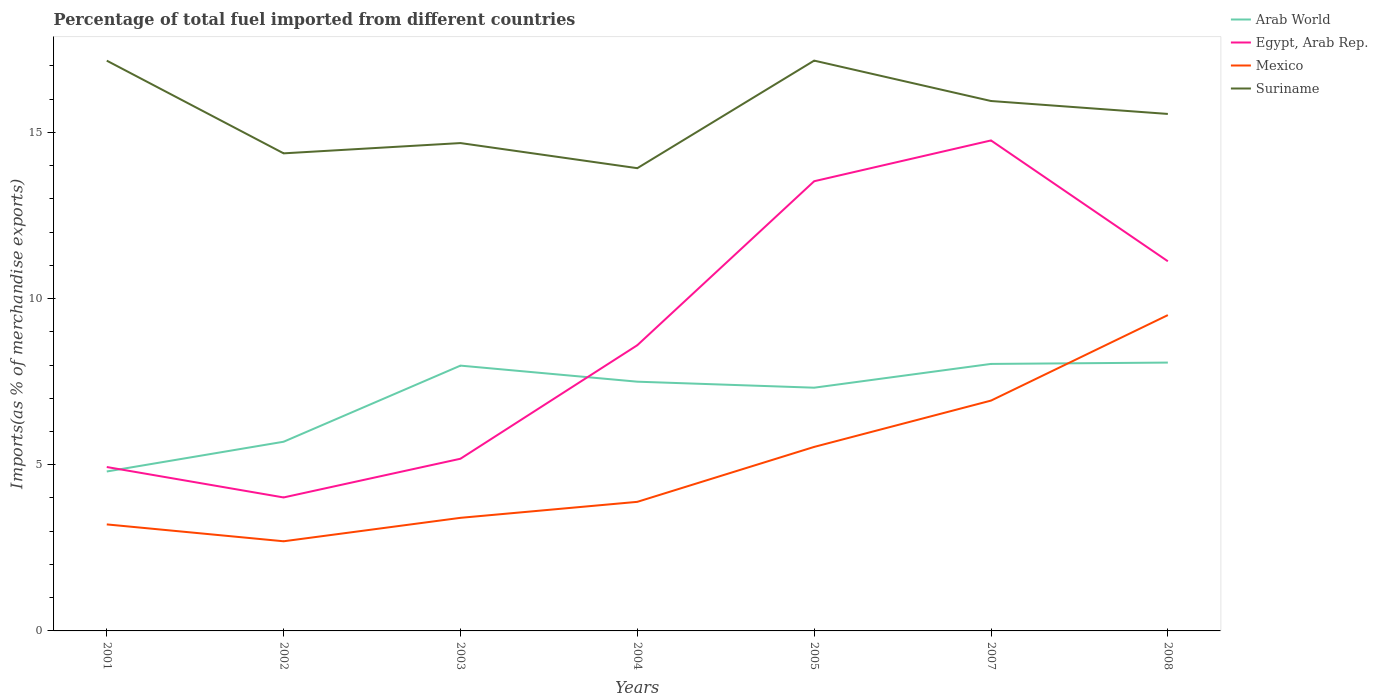How many different coloured lines are there?
Keep it short and to the point. 4. Does the line corresponding to Suriname intersect with the line corresponding to Egypt, Arab Rep.?
Your response must be concise. No. Is the number of lines equal to the number of legend labels?
Provide a short and direct response. Yes. Across all years, what is the maximum percentage of imports to different countries in Arab World?
Keep it short and to the point. 4.8. What is the total percentage of imports to different countries in Mexico in the graph?
Your answer should be very brief. -3.73. What is the difference between the highest and the second highest percentage of imports to different countries in Suriname?
Make the answer very short. 3.24. Is the percentage of imports to different countries in Egypt, Arab Rep. strictly greater than the percentage of imports to different countries in Mexico over the years?
Offer a terse response. No. How many lines are there?
Make the answer very short. 4. What is the difference between two consecutive major ticks on the Y-axis?
Your answer should be compact. 5. Does the graph contain any zero values?
Provide a short and direct response. No. Does the graph contain grids?
Give a very brief answer. No. Where does the legend appear in the graph?
Your answer should be very brief. Top right. How many legend labels are there?
Your response must be concise. 4. How are the legend labels stacked?
Your response must be concise. Vertical. What is the title of the graph?
Provide a succinct answer. Percentage of total fuel imported from different countries. What is the label or title of the X-axis?
Offer a very short reply. Years. What is the label or title of the Y-axis?
Your answer should be compact. Imports(as % of merchandise exports). What is the Imports(as % of merchandise exports) of Arab World in 2001?
Give a very brief answer. 4.8. What is the Imports(as % of merchandise exports) in Egypt, Arab Rep. in 2001?
Keep it short and to the point. 4.93. What is the Imports(as % of merchandise exports) of Mexico in 2001?
Keep it short and to the point. 3.21. What is the Imports(as % of merchandise exports) of Suriname in 2001?
Provide a short and direct response. 17.16. What is the Imports(as % of merchandise exports) of Arab World in 2002?
Your response must be concise. 5.69. What is the Imports(as % of merchandise exports) of Egypt, Arab Rep. in 2002?
Ensure brevity in your answer.  4.02. What is the Imports(as % of merchandise exports) of Mexico in 2002?
Provide a short and direct response. 2.7. What is the Imports(as % of merchandise exports) of Suriname in 2002?
Your answer should be compact. 14.37. What is the Imports(as % of merchandise exports) of Arab World in 2003?
Keep it short and to the point. 7.98. What is the Imports(as % of merchandise exports) of Egypt, Arab Rep. in 2003?
Provide a succinct answer. 5.18. What is the Imports(as % of merchandise exports) in Mexico in 2003?
Make the answer very short. 3.4. What is the Imports(as % of merchandise exports) of Suriname in 2003?
Make the answer very short. 14.68. What is the Imports(as % of merchandise exports) in Arab World in 2004?
Provide a succinct answer. 7.5. What is the Imports(as % of merchandise exports) of Egypt, Arab Rep. in 2004?
Provide a short and direct response. 8.6. What is the Imports(as % of merchandise exports) of Mexico in 2004?
Your answer should be very brief. 3.88. What is the Imports(as % of merchandise exports) of Suriname in 2004?
Keep it short and to the point. 13.92. What is the Imports(as % of merchandise exports) in Arab World in 2005?
Offer a very short reply. 7.32. What is the Imports(as % of merchandise exports) in Egypt, Arab Rep. in 2005?
Make the answer very short. 13.53. What is the Imports(as % of merchandise exports) in Mexico in 2005?
Offer a very short reply. 5.54. What is the Imports(as % of merchandise exports) in Suriname in 2005?
Keep it short and to the point. 17.16. What is the Imports(as % of merchandise exports) in Arab World in 2007?
Provide a short and direct response. 8.03. What is the Imports(as % of merchandise exports) of Egypt, Arab Rep. in 2007?
Provide a short and direct response. 14.76. What is the Imports(as % of merchandise exports) in Mexico in 2007?
Provide a succinct answer. 6.93. What is the Imports(as % of merchandise exports) of Suriname in 2007?
Your answer should be compact. 15.95. What is the Imports(as % of merchandise exports) in Arab World in 2008?
Ensure brevity in your answer.  8.07. What is the Imports(as % of merchandise exports) of Egypt, Arab Rep. in 2008?
Your answer should be compact. 11.12. What is the Imports(as % of merchandise exports) of Mexico in 2008?
Offer a very short reply. 9.5. What is the Imports(as % of merchandise exports) of Suriname in 2008?
Give a very brief answer. 15.56. Across all years, what is the maximum Imports(as % of merchandise exports) of Arab World?
Your response must be concise. 8.07. Across all years, what is the maximum Imports(as % of merchandise exports) in Egypt, Arab Rep.?
Offer a terse response. 14.76. Across all years, what is the maximum Imports(as % of merchandise exports) of Mexico?
Offer a terse response. 9.5. Across all years, what is the maximum Imports(as % of merchandise exports) of Suriname?
Provide a succinct answer. 17.16. Across all years, what is the minimum Imports(as % of merchandise exports) of Arab World?
Provide a short and direct response. 4.8. Across all years, what is the minimum Imports(as % of merchandise exports) of Egypt, Arab Rep.?
Your response must be concise. 4.02. Across all years, what is the minimum Imports(as % of merchandise exports) in Mexico?
Keep it short and to the point. 2.7. Across all years, what is the minimum Imports(as % of merchandise exports) in Suriname?
Provide a short and direct response. 13.92. What is the total Imports(as % of merchandise exports) in Arab World in the graph?
Your response must be concise. 49.4. What is the total Imports(as % of merchandise exports) in Egypt, Arab Rep. in the graph?
Your response must be concise. 62.14. What is the total Imports(as % of merchandise exports) in Mexico in the graph?
Make the answer very short. 35.16. What is the total Imports(as % of merchandise exports) of Suriname in the graph?
Make the answer very short. 108.8. What is the difference between the Imports(as % of merchandise exports) of Arab World in 2001 and that in 2002?
Make the answer very short. -0.9. What is the difference between the Imports(as % of merchandise exports) of Egypt, Arab Rep. in 2001 and that in 2002?
Your response must be concise. 0.92. What is the difference between the Imports(as % of merchandise exports) of Mexico in 2001 and that in 2002?
Your answer should be very brief. 0.51. What is the difference between the Imports(as % of merchandise exports) of Suriname in 2001 and that in 2002?
Offer a very short reply. 2.79. What is the difference between the Imports(as % of merchandise exports) in Arab World in 2001 and that in 2003?
Give a very brief answer. -3.19. What is the difference between the Imports(as % of merchandise exports) of Egypt, Arab Rep. in 2001 and that in 2003?
Give a very brief answer. -0.25. What is the difference between the Imports(as % of merchandise exports) of Mexico in 2001 and that in 2003?
Offer a terse response. -0.2. What is the difference between the Imports(as % of merchandise exports) in Suriname in 2001 and that in 2003?
Give a very brief answer. 2.48. What is the difference between the Imports(as % of merchandise exports) of Arab World in 2001 and that in 2004?
Provide a succinct answer. -2.7. What is the difference between the Imports(as % of merchandise exports) of Egypt, Arab Rep. in 2001 and that in 2004?
Ensure brevity in your answer.  -3.67. What is the difference between the Imports(as % of merchandise exports) of Mexico in 2001 and that in 2004?
Ensure brevity in your answer.  -0.68. What is the difference between the Imports(as % of merchandise exports) in Suriname in 2001 and that in 2004?
Provide a succinct answer. 3.24. What is the difference between the Imports(as % of merchandise exports) of Arab World in 2001 and that in 2005?
Make the answer very short. -2.52. What is the difference between the Imports(as % of merchandise exports) of Egypt, Arab Rep. in 2001 and that in 2005?
Your answer should be compact. -8.6. What is the difference between the Imports(as % of merchandise exports) in Mexico in 2001 and that in 2005?
Your answer should be compact. -2.33. What is the difference between the Imports(as % of merchandise exports) in Suriname in 2001 and that in 2005?
Give a very brief answer. -0. What is the difference between the Imports(as % of merchandise exports) in Arab World in 2001 and that in 2007?
Make the answer very short. -3.24. What is the difference between the Imports(as % of merchandise exports) in Egypt, Arab Rep. in 2001 and that in 2007?
Give a very brief answer. -9.83. What is the difference between the Imports(as % of merchandise exports) in Mexico in 2001 and that in 2007?
Your response must be concise. -3.73. What is the difference between the Imports(as % of merchandise exports) in Suriname in 2001 and that in 2007?
Provide a short and direct response. 1.21. What is the difference between the Imports(as % of merchandise exports) of Arab World in 2001 and that in 2008?
Give a very brief answer. -3.28. What is the difference between the Imports(as % of merchandise exports) of Egypt, Arab Rep. in 2001 and that in 2008?
Ensure brevity in your answer.  -6.19. What is the difference between the Imports(as % of merchandise exports) of Mexico in 2001 and that in 2008?
Offer a terse response. -6.3. What is the difference between the Imports(as % of merchandise exports) of Suriname in 2001 and that in 2008?
Offer a very short reply. 1.6. What is the difference between the Imports(as % of merchandise exports) in Arab World in 2002 and that in 2003?
Provide a succinct answer. -2.29. What is the difference between the Imports(as % of merchandise exports) in Egypt, Arab Rep. in 2002 and that in 2003?
Offer a very short reply. -1.16. What is the difference between the Imports(as % of merchandise exports) of Mexico in 2002 and that in 2003?
Give a very brief answer. -0.71. What is the difference between the Imports(as % of merchandise exports) of Suriname in 2002 and that in 2003?
Ensure brevity in your answer.  -0.31. What is the difference between the Imports(as % of merchandise exports) in Arab World in 2002 and that in 2004?
Offer a terse response. -1.81. What is the difference between the Imports(as % of merchandise exports) in Egypt, Arab Rep. in 2002 and that in 2004?
Your response must be concise. -4.58. What is the difference between the Imports(as % of merchandise exports) in Mexico in 2002 and that in 2004?
Give a very brief answer. -1.19. What is the difference between the Imports(as % of merchandise exports) of Suriname in 2002 and that in 2004?
Make the answer very short. 0.45. What is the difference between the Imports(as % of merchandise exports) of Arab World in 2002 and that in 2005?
Provide a succinct answer. -1.63. What is the difference between the Imports(as % of merchandise exports) in Egypt, Arab Rep. in 2002 and that in 2005?
Provide a succinct answer. -9.51. What is the difference between the Imports(as % of merchandise exports) of Mexico in 2002 and that in 2005?
Provide a succinct answer. -2.84. What is the difference between the Imports(as % of merchandise exports) in Suriname in 2002 and that in 2005?
Offer a very short reply. -2.79. What is the difference between the Imports(as % of merchandise exports) in Arab World in 2002 and that in 2007?
Offer a very short reply. -2.34. What is the difference between the Imports(as % of merchandise exports) in Egypt, Arab Rep. in 2002 and that in 2007?
Make the answer very short. -10.74. What is the difference between the Imports(as % of merchandise exports) of Mexico in 2002 and that in 2007?
Offer a terse response. -4.23. What is the difference between the Imports(as % of merchandise exports) of Suriname in 2002 and that in 2007?
Your answer should be compact. -1.57. What is the difference between the Imports(as % of merchandise exports) of Arab World in 2002 and that in 2008?
Give a very brief answer. -2.38. What is the difference between the Imports(as % of merchandise exports) in Egypt, Arab Rep. in 2002 and that in 2008?
Make the answer very short. -7.11. What is the difference between the Imports(as % of merchandise exports) of Mexico in 2002 and that in 2008?
Your answer should be compact. -6.81. What is the difference between the Imports(as % of merchandise exports) of Suriname in 2002 and that in 2008?
Provide a short and direct response. -1.19. What is the difference between the Imports(as % of merchandise exports) in Arab World in 2003 and that in 2004?
Provide a succinct answer. 0.48. What is the difference between the Imports(as % of merchandise exports) in Egypt, Arab Rep. in 2003 and that in 2004?
Your response must be concise. -3.42. What is the difference between the Imports(as % of merchandise exports) in Mexico in 2003 and that in 2004?
Ensure brevity in your answer.  -0.48. What is the difference between the Imports(as % of merchandise exports) of Suriname in 2003 and that in 2004?
Provide a succinct answer. 0.76. What is the difference between the Imports(as % of merchandise exports) of Arab World in 2003 and that in 2005?
Ensure brevity in your answer.  0.66. What is the difference between the Imports(as % of merchandise exports) in Egypt, Arab Rep. in 2003 and that in 2005?
Ensure brevity in your answer.  -8.35. What is the difference between the Imports(as % of merchandise exports) in Mexico in 2003 and that in 2005?
Offer a very short reply. -2.13. What is the difference between the Imports(as % of merchandise exports) of Suriname in 2003 and that in 2005?
Your answer should be very brief. -2.48. What is the difference between the Imports(as % of merchandise exports) in Arab World in 2003 and that in 2007?
Offer a very short reply. -0.05. What is the difference between the Imports(as % of merchandise exports) in Egypt, Arab Rep. in 2003 and that in 2007?
Give a very brief answer. -9.58. What is the difference between the Imports(as % of merchandise exports) in Mexico in 2003 and that in 2007?
Offer a very short reply. -3.53. What is the difference between the Imports(as % of merchandise exports) of Suriname in 2003 and that in 2007?
Your answer should be very brief. -1.27. What is the difference between the Imports(as % of merchandise exports) in Arab World in 2003 and that in 2008?
Provide a short and direct response. -0.09. What is the difference between the Imports(as % of merchandise exports) of Egypt, Arab Rep. in 2003 and that in 2008?
Offer a very short reply. -5.94. What is the difference between the Imports(as % of merchandise exports) of Mexico in 2003 and that in 2008?
Provide a succinct answer. -6.1. What is the difference between the Imports(as % of merchandise exports) in Suriname in 2003 and that in 2008?
Offer a terse response. -0.88. What is the difference between the Imports(as % of merchandise exports) of Arab World in 2004 and that in 2005?
Ensure brevity in your answer.  0.18. What is the difference between the Imports(as % of merchandise exports) of Egypt, Arab Rep. in 2004 and that in 2005?
Your response must be concise. -4.93. What is the difference between the Imports(as % of merchandise exports) of Mexico in 2004 and that in 2005?
Your answer should be very brief. -1.65. What is the difference between the Imports(as % of merchandise exports) of Suriname in 2004 and that in 2005?
Offer a terse response. -3.24. What is the difference between the Imports(as % of merchandise exports) in Arab World in 2004 and that in 2007?
Your response must be concise. -0.53. What is the difference between the Imports(as % of merchandise exports) in Egypt, Arab Rep. in 2004 and that in 2007?
Offer a terse response. -6.16. What is the difference between the Imports(as % of merchandise exports) of Mexico in 2004 and that in 2007?
Your answer should be very brief. -3.05. What is the difference between the Imports(as % of merchandise exports) in Suriname in 2004 and that in 2007?
Offer a very short reply. -2.02. What is the difference between the Imports(as % of merchandise exports) in Arab World in 2004 and that in 2008?
Your response must be concise. -0.57. What is the difference between the Imports(as % of merchandise exports) of Egypt, Arab Rep. in 2004 and that in 2008?
Offer a terse response. -2.53. What is the difference between the Imports(as % of merchandise exports) in Mexico in 2004 and that in 2008?
Your answer should be very brief. -5.62. What is the difference between the Imports(as % of merchandise exports) of Suriname in 2004 and that in 2008?
Offer a very short reply. -1.63. What is the difference between the Imports(as % of merchandise exports) in Arab World in 2005 and that in 2007?
Offer a very short reply. -0.72. What is the difference between the Imports(as % of merchandise exports) of Egypt, Arab Rep. in 2005 and that in 2007?
Offer a terse response. -1.23. What is the difference between the Imports(as % of merchandise exports) in Mexico in 2005 and that in 2007?
Your response must be concise. -1.39. What is the difference between the Imports(as % of merchandise exports) in Suriname in 2005 and that in 2007?
Your answer should be compact. 1.22. What is the difference between the Imports(as % of merchandise exports) in Arab World in 2005 and that in 2008?
Your response must be concise. -0.76. What is the difference between the Imports(as % of merchandise exports) in Egypt, Arab Rep. in 2005 and that in 2008?
Keep it short and to the point. 2.41. What is the difference between the Imports(as % of merchandise exports) in Mexico in 2005 and that in 2008?
Provide a succinct answer. -3.97. What is the difference between the Imports(as % of merchandise exports) of Suriname in 2005 and that in 2008?
Provide a short and direct response. 1.6. What is the difference between the Imports(as % of merchandise exports) in Arab World in 2007 and that in 2008?
Offer a very short reply. -0.04. What is the difference between the Imports(as % of merchandise exports) of Egypt, Arab Rep. in 2007 and that in 2008?
Provide a succinct answer. 3.64. What is the difference between the Imports(as % of merchandise exports) in Mexico in 2007 and that in 2008?
Provide a short and direct response. -2.57. What is the difference between the Imports(as % of merchandise exports) in Suriname in 2007 and that in 2008?
Keep it short and to the point. 0.39. What is the difference between the Imports(as % of merchandise exports) of Arab World in 2001 and the Imports(as % of merchandise exports) of Egypt, Arab Rep. in 2002?
Give a very brief answer. 0.78. What is the difference between the Imports(as % of merchandise exports) in Arab World in 2001 and the Imports(as % of merchandise exports) in Mexico in 2002?
Provide a short and direct response. 2.1. What is the difference between the Imports(as % of merchandise exports) of Arab World in 2001 and the Imports(as % of merchandise exports) of Suriname in 2002?
Provide a succinct answer. -9.57. What is the difference between the Imports(as % of merchandise exports) in Egypt, Arab Rep. in 2001 and the Imports(as % of merchandise exports) in Mexico in 2002?
Give a very brief answer. 2.23. What is the difference between the Imports(as % of merchandise exports) in Egypt, Arab Rep. in 2001 and the Imports(as % of merchandise exports) in Suriname in 2002?
Give a very brief answer. -9.44. What is the difference between the Imports(as % of merchandise exports) of Mexico in 2001 and the Imports(as % of merchandise exports) of Suriname in 2002?
Your response must be concise. -11.17. What is the difference between the Imports(as % of merchandise exports) of Arab World in 2001 and the Imports(as % of merchandise exports) of Egypt, Arab Rep. in 2003?
Your answer should be very brief. -0.38. What is the difference between the Imports(as % of merchandise exports) of Arab World in 2001 and the Imports(as % of merchandise exports) of Mexico in 2003?
Provide a succinct answer. 1.39. What is the difference between the Imports(as % of merchandise exports) of Arab World in 2001 and the Imports(as % of merchandise exports) of Suriname in 2003?
Your answer should be very brief. -9.88. What is the difference between the Imports(as % of merchandise exports) of Egypt, Arab Rep. in 2001 and the Imports(as % of merchandise exports) of Mexico in 2003?
Keep it short and to the point. 1.53. What is the difference between the Imports(as % of merchandise exports) in Egypt, Arab Rep. in 2001 and the Imports(as % of merchandise exports) in Suriname in 2003?
Your answer should be very brief. -9.75. What is the difference between the Imports(as % of merchandise exports) in Mexico in 2001 and the Imports(as % of merchandise exports) in Suriname in 2003?
Keep it short and to the point. -11.47. What is the difference between the Imports(as % of merchandise exports) of Arab World in 2001 and the Imports(as % of merchandise exports) of Egypt, Arab Rep. in 2004?
Your answer should be compact. -3.8. What is the difference between the Imports(as % of merchandise exports) in Arab World in 2001 and the Imports(as % of merchandise exports) in Mexico in 2004?
Offer a terse response. 0.91. What is the difference between the Imports(as % of merchandise exports) in Arab World in 2001 and the Imports(as % of merchandise exports) in Suriname in 2004?
Offer a terse response. -9.13. What is the difference between the Imports(as % of merchandise exports) of Egypt, Arab Rep. in 2001 and the Imports(as % of merchandise exports) of Mexico in 2004?
Your answer should be very brief. 1.05. What is the difference between the Imports(as % of merchandise exports) of Egypt, Arab Rep. in 2001 and the Imports(as % of merchandise exports) of Suriname in 2004?
Give a very brief answer. -8.99. What is the difference between the Imports(as % of merchandise exports) of Mexico in 2001 and the Imports(as % of merchandise exports) of Suriname in 2004?
Ensure brevity in your answer.  -10.72. What is the difference between the Imports(as % of merchandise exports) in Arab World in 2001 and the Imports(as % of merchandise exports) in Egypt, Arab Rep. in 2005?
Your response must be concise. -8.73. What is the difference between the Imports(as % of merchandise exports) of Arab World in 2001 and the Imports(as % of merchandise exports) of Mexico in 2005?
Offer a very short reply. -0.74. What is the difference between the Imports(as % of merchandise exports) in Arab World in 2001 and the Imports(as % of merchandise exports) in Suriname in 2005?
Make the answer very short. -12.36. What is the difference between the Imports(as % of merchandise exports) in Egypt, Arab Rep. in 2001 and the Imports(as % of merchandise exports) in Mexico in 2005?
Ensure brevity in your answer.  -0.6. What is the difference between the Imports(as % of merchandise exports) of Egypt, Arab Rep. in 2001 and the Imports(as % of merchandise exports) of Suriname in 2005?
Ensure brevity in your answer.  -12.23. What is the difference between the Imports(as % of merchandise exports) of Mexico in 2001 and the Imports(as % of merchandise exports) of Suriname in 2005?
Make the answer very short. -13.96. What is the difference between the Imports(as % of merchandise exports) in Arab World in 2001 and the Imports(as % of merchandise exports) in Egypt, Arab Rep. in 2007?
Provide a short and direct response. -9.96. What is the difference between the Imports(as % of merchandise exports) of Arab World in 2001 and the Imports(as % of merchandise exports) of Mexico in 2007?
Keep it short and to the point. -2.13. What is the difference between the Imports(as % of merchandise exports) in Arab World in 2001 and the Imports(as % of merchandise exports) in Suriname in 2007?
Offer a terse response. -11.15. What is the difference between the Imports(as % of merchandise exports) of Egypt, Arab Rep. in 2001 and the Imports(as % of merchandise exports) of Mexico in 2007?
Offer a terse response. -2. What is the difference between the Imports(as % of merchandise exports) of Egypt, Arab Rep. in 2001 and the Imports(as % of merchandise exports) of Suriname in 2007?
Keep it short and to the point. -11.01. What is the difference between the Imports(as % of merchandise exports) of Mexico in 2001 and the Imports(as % of merchandise exports) of Suriname in 2007?
Give a very brief answer. -12.74. What is the difference between the Imports(as % of merchandise exports) in Arab World in 2001 and the Imports(as % of merchandise exports) in Egypt, Arab Rep. in 2008?
Make the answer very short. -6.33. What is the difference between the Imports(as % of merchandise exports) in Arab World in 2001 and the Imports(as % of merchandise exports) in Mexico in 2008?
Provide a succinct answer. -4.71. What is the difference between the Imports(as % of merchandise exports) of Arab World in 2001 and the Imports(as % of merchandise exports) of Suriname in 2008?
Make the answer very short. -10.76. What is the difference between the Imports(as % of merchandise exports) of Egypt, Arab Rep. in 2001 and the Imports(as % of merchandise exports) of Mexico in 2008?
Your answer should be compact. -4.57. What is the difference between the Imports(as % of merchandise exports) in Egypt, Arab Rep. in 2001 and the Imports(as % of merchandise exports) in Suriname in 2008?
Give a very brief answer. -10.62. What is the difference between the Imports(as % of merchandise exports) of Mexico in 2001 and the Imports(as % of merchandise exports) of Suriname in 2008?
Keep it short and to the point. -12.35. What is the difference between the Imports(as % of merchandise exports) in Arab World in 2002 and the Imports(as % of merchandise exports) in Egypt, Arab Rep. in 2003?
Ensure brevity in your answer.  0.51. What is the difference between the Imports(as % of merchandise exports) in Arab World in 2002 and the Imports(as % of merchandise exports) in Mexico in 2003?
Provide a short and direct response. 2.29. What is the difference between the Imports(as % of merchandise exports) of Arab World in 2002 and the Imports(as % of merchandise exports) of Suriname in 2003?
Provide a succinct answer. -8.99. What is the difference between the Imports(as % of merchandise exports) of Egypt, Arab Rep. in 2002 and the Imports(as % of merchandise exports) of Mexico in 2003?
Offer a very short reply. 0.61. What is the difference between the Imports(as % of merchandise exports) in Egypt, Arab Rep. in 2002 and the Imports(as % of merchandise exports) in Suriname in 2003?
Provide a short and direct response. -10.66. What is the difference between the Imports(as % of merchandise exports) of Mexico in 2002 and the Imports(as % of merchandise exports) of Suriname in 2003?
Give a very brief answer. -11.98. What is the difference between the Imports(as % of merchandise exports) of Arab World in 2002 and the Imports(as % of merchandise exports) of Egypt, Arab Rep. in 2004?
Offer a very short reply. -2.9. What is the difference between the Imports(as % of merchandise exports) of Arab World in 2002 and the Imports(as % of merchandise exports) of Mexico in 2004?
Make the answer very short. 1.81. What is the difference between the Imports(as % of merchandise exports) in Arab World in 2002 and the Imports(as % of merchandise exports) in Suriname in 2004?
Offer a very short reply. -8.23. What is the difference between the Imports(as % of merchandise exports) of Egypt, Arab Rep. in 2002 and the Imports(as % of merchandise exports) of Mexico in 2004?
Make the answer very short. 0.13. What is the difference between the Imports(as % of merchandise exports) in Egypt, Arab Rep. in 2002 and the Imports(as % of merchandise exports) in Suriname in 2004?
Provide a short and direct response. -9.91. What is the difference between the Imports(as % of merchandise exports) of Mexico in 2002 and the Imports(as % of merchandise exports) of Suriname in 2004?
Make the answer very short. -11.23. What is the difference between the Imports(as % of merchandise exports) in Arab World in 2002 and the Imports(as % of merchandise exports) in Egypt, Arab Rep. in 2005?
Ensure brevity in your answer.  -7.84. What is the difference between the Imports(as % of merchandise exports) in Arab World in 2002 and the Imports(as % of merchandise exports) in Mexico in 2005?
Give a very brief answer. 0.16. What is the difference between the Imports(as % of merchandise exports) in Arab World in 2002 and the Imports(as % of merchandise exports) in Suriname in 2005?
Ensure brevity in your answer.  -11.47. What is the difference between the Imports(as % of merchandise exports) of Egypt, Arab Rep. in 2002 and the Imports(as % of merchandise exports) of Mexico in 2005?
Ensure brevity in your answer.  -1.52. What is the difference between the Imports(as % of merchandise exports) in Egypt, Arab Rep. in 2002 and the Imports(as % of merchandise exports) in Suriname in 2005?
Ensure brevity in your answer.  -13.14. What is the difference between the Imports(as % of merchandise exports) in Mexico in 2002 and the Imports(as % of merchandise exports) in Suriname in 2005?
Keep it short and to the point. -14.46. What is the difference between the Imports(as % of merchandise exports) of Arab World in 2002 and the Imports(as % of merchandise exports) of Egypt, Arab Rep. in 2007?
Provide a short and direct response. -9.07. What is the difference between the Imports(as % of merchandise exports) in Arab World in 2002 and the Imports(as % of merchandise exports) in Mexico in 2007?
Your response must be concise. -1.24. What is the difference between the Imports(as % of merchandise exports) of Arab World in 2002 and the Imports(as % of merchandise exports) of Suriname in 2007?
Your response must be concise. -10.25. What is the difference between the Imports(as % of merchandise exports) in Egypt, Arab Rep. in 2002 and the Imports(as % of merchandise exports) in Mexico in 2007?
Provide a short and direct response. -2.91. What is the difference between the Imports(as % of merchandise exports) in Egypt, Arab Rep. in 2002 and the Imports(as % of merchandise exports) in Suriname in 2007?
Your answer should be very brief. -11.93. What is the difference between the Imports(as % of merchandise exports) of Mexico in 2002 and the Imports(as % of merchandise exports) of Suriname in 2007?
Your answer should be compact. -13.25. What is the difference between the Imports(as % of merchandise exports) in Arab World in 2002 and the Imports(as % of merchandise exports) in Egypt, Arab Rep. in 2008?
Your answer should be compact. -5.43. What is the difference between the Imports(as % of merchandise exports) in Arab World in 2002 and the Imports(as % of merchandise exports) in Mexico in 2008?
Ensure brevity in your answer.  -3.81. What is the difference between the Imports(as % of merchandise exports) of Arab World in 2002 and the Imports(as % of merchandise exports) of Suriname in 2008?
Keep it short and to the point. -9.86. What is the difference between the Imports(as % of merchandise exports) of Egypt, Arab Rep. in 2002 and the Imports(as % of merchandise exports) of Mexico in 2008?
Your answer should be very brief. -5.49. What is the difference between the Imports(as % of merchandise exports) in Egypt, Arab Rep. in 2002 and the Imports(as % of merchandise exports) in Suriname in 2008?
Your response must be concise. -11.54. What is the difference between the Imports(as % of merchandise exports) of Mexico in 2002 and the Imports(as % of merchandise exports) of Suriname in 2008?
Offer a terse response. -12.86. What is the difference between the Imports(as % of merchandise exports) in Arab World in 2003 and the Imports(as % of merchandise exports) in Egypt, Arab Rep. in 2004?
Give a very brief answer. -0.61. What is the difference between the Imports(as % of merchandise exports) in Arab World in 2003 and the Imports(as % of merchandise exports) in Mexico in 2004?
Ensure brevity in your answer.  4.1. What is the difference between the Imports(as % of merchandise exports) of Arab World in 2003 and the Imports(as % of merchandise exports) of Suriname in 2004?
Give a very brief answer. -5.94. What is the difference between the Imports(as % of merchandise exports) in Egypt, Arab Rep. in 2003 and the Imports(as % of merchandise exports) in Mexico in 2004?
Provide a succinct answer. 1.3. What is the difference between the Imports(as % of merchandise exports) of Egypt, Arab Rep. in 2003 and the Imports(as % of merchandise exports) of Suriname in 2004?
Offer a terse response. -8.74. What is the difference between the Imports(as % of merchandise exports) of Mexico in 2003 and the Imports(as % of merchandise exports) of Suriname in 2004?
Your answer should be compact. -10.52. What is the difference between the Imports(as % of merchandise exports) of Arab World in 2003 and the Imports(as % of merchandise exports) of Egypt, Arab Rep. in 2005?
Provide a succinct answer. -5.55. What is the difference between the Imports(as % of merchandise exports) of Arab World in 2003 and the Imports(as % of merchandise exports) of Mexico in 2005?
Your answer should be very brief. 2.45. What is the difference between the Imports(as % of merchandise exports) in Arab World in 2003 and the Imports(as % of merchandise exports) in Suriname in 2005?
Provide a short and direct response. -9.18. What is the difference between the Imports(as % of merchandise exports) in Egypt, Arab Rep. in 2003 and the Imports(as % of merchandise exports) in Mexico in 2005?
Your answer should be compact. -0.36. What is the difference between the Imports(as % of merchandise exports) of Egypt, Arab Rep. in 2003 and the Imports(as % of merchandise exports) of Suriname in 2005?
Give a very brief answer. -11.98. What is the difference between the Imports(as % of merchandise exports) of Mexico in 2003 and the Imports(as % of merchandise exports) of Suriname in 2005?
Keep it short and to the point. -13.76. What is the difference between the Imports(as % of merchandise exports) of Arab World in 2003 and the Imports(as % of merchandise exports) of Egypt, Arab Rep. in 2007?
Your answer should be compact. -6.78. What is the difference between the Imports(as % of merchandise exports) in Arab World in 2003 and the Imports(as % of merchandise exports) in Mexico in 2007?
Your answer should be very brief. 1.05. What is the difference between the Imports(as % of merchandise exports) in Arab World in 2003 and the Imports(as % of merchandise exports) in Suriname in 2007?
Ensure brevity in your answer.  -7.96. What is the difference between the Imports(as % of merchandise exports) in Egypt, Arab Rep. in 2003 and the Imports(as % of merchandise exports) in Mexico in 2007?
Provide a short and direct response. -1.75. What is the difference between the Imports(as % of merchandise exports) of Egypt, Arab Rep. in 2003 and the Imports(as % of merchandise exports) of Suriname in 2007?
Your answer should be compact. -10.76. What is the difference between the Imports(as % of merchandise exports) of Mexico in 2003 and the Imports(as % of merchandise exports) of Suriname in 2007?
Your answer should be compact. -12.54. What is the difference between the Imports(as % of merchandise exports) in Arab World in 2003 and the Imports(as % of merchandise exports) in Egypt, Arab Rep. in 2008?
Your answer should be compact. -3.14. What is the difference between the Imports(as % of merchandise exports) of Arab World in 2003 and the Imports(as % of merchandise exports) of Mexico in 2008?
Provide a short and direct response. -1.52. What is the difference between the Imports(as % of merchandise exports) in Arab World in 2003 and the Imports(as % of merchandise exports) in Suriname in 2008?
Make the answer very short. -7.57. What is the difference between the Imports(as % of merchandise exports) of Egypt, Arab Rep. in 2003 and the Imports(as % of merchandise exports) of Mexico in 2008?
Give a very brief answer. -4.32. What is the difference between the Imports(as % of merchandise exports) in Egypt, Arab Rep. in 2003 and the Imports(as % of merchandise exports) in Suriname in 2008?
Ensure brevity in your answer.  -10.38. What is the difference between the Imports(as % of merchandise exports) in Mexico in 2003 and the Imports(as % of merchandise exports) in Suriname in 2008?
Give a very brief answer. -12.15. What is the difference between the Imports(as % of merchandise exports) in Arab World in 2004 and the Imports(as % of merchandise exports) in Egypt, Arab Rep. in 2005?
Provide a succinct answer. -6.03. What is the difference between the Imports(as % of merchandise exports) in Arab World in 2004 and the Imports(as % of merchandise exports) in Mexico in 2005?
Give a very brief answer. 1.96. What is the difference between the Imports(as % of merchandise exports) of Arab World in 2004 and the Imports(as % of merchandise exports) of Suriname in 2005?
Offer a very short reply. -9.66. What is the difference between the Imports(as % of merchandise exports) in Egypt, Arab Rep. in 2004 and the Imports(as % of merchandise exports) in Mexico in 2005?
Your answer should be compact. 3.06. What is the difference between the Imports(as % of merchandise exports) in Egypt, Arab Rep. in 2004 and the Imports(as % of merchandise exports) in Suriname in 2005?
Offer a very short reply. -8.56. What is the difference between the Imports(as % of merchandise exports) in Mexico in 2004 and the Imports(as % of merchandise exports) in Suriname in 2005?
Give a very brief answer. -13.28. What is the difference between the Imports(as % of merchandise exports) of Arab World in 2004 and the Imports(as % of merchandise exports) of Egypt, Arab Rep. in 2007?
Give a very brief answer. -7.26. What is the difference between the Imports(as % of merchandise exports) in Arab World in 2004 and the Imports(as % of merchandise exports) in Mexico in 2007?
Keep it short and to the point. 0.57. What is the difference between the Imports(as % of merchandise exports) in Arab World in 2004 and the Imports(as % of merchandise exports) in Suriname in 2007?
Your answer should be compact. -8.45. What is the difference between the Imports(as % of merchandise exports) of Egypt, Arab Rep. in 2004 and the Imports(as % of merchandise exports) of Mexico in 2007?
Keep it short and to the point. 1.67. What is the difference between the Imports(as % of merchandise exports) of Egypt, Arab Rep. in 2004 and the Imports(as % of merchandise exports) of Suriname in 2007?
Your answer should be compact. -7.35. What is the difference between the Imports(as % of merchandise exports) of Mexico in 2004 and the Imports(as % of merchandise exports) of Suriname in 2007?
Give a very brief answer. -12.06. What is the difference between the Imports(as % of merchandise exports) of Arab World in 2004 and the Imports(as % of merchandise exports) of Egypt, Arab Rep. in 2008?
Provide a short and direct response. -3.62. What is the difference between the Imports(as % of merchandise exports) of Arab World in 2004 and the Imports(as % of merchandise exports) of Mexico in 2008?
Provide a short and direct response. -2. What is the difference between the Imports(as % of merchandise exports) of Arab World in 2004 and the Imports(as % of merchandise exports) of Suriname in 2008?
Make the answer very short. -8.06. What is the difference between the Imports(as % of merchandise exports) in Egypt, Arab Rep. in 2004 and the Imports(as % of merchandise exports) in Mexico in 2008?
Your answer should be compact. -0.91. What is the difference between the Imports(as % of merchandise exports) of Egypt, Arab Rep. in 2004 and the Imports(as % of merchandise exports) of Suriname in 2008?
Give a very brief answer. -6.96. What is the difference between the Imports(as % of merchandise exports) of Mexico in 2004 and the Imports(as % of merchandise exports) of Suriname in 2008?
Your answer should be very brief. -11.67. What is the difference between the Imports(as % of merchandise exports) of Arab World in 2005 and the Imports(as % of merchandise exports) of Egypt, Arab Rep. in 2007?
Offer a very short reply. -7.44. What is the difference between the Imports(as % of merchandise exports) in Arab World in 2005 and the Imports(as % of merchandise exports) in Mexico in 2007?
Your answer should be very brief. 0.39. What is the difference between the Imports(as % of merchandise exports) of Arab World in 2005 and the Imports(as % of merchandise exports) of Suriname in 2007?
Keep it short and to the point. -8.63. What is the difference between the Imports(as % of merchandise exports) in Egypt, Arab Rep. in 2005 and the Imports(as % of merchandise exports) in Mexico in 2007?
Your answer should be compact. 6.6. What is the difference between the Imports(as % of merchandise exports) of Egypt, Arab Rep. in 2005 and the Imports(as % of merchandise exports) of Suriname in 2007?
Give a very brief answer. -2.41. What is the difference between the Imports(as % of merchandise exports) in Mexico in 2005 and the Imports(as % of merchandise exports) in Suriname in 2007?
Your answer should be compact. -10.41. What is the difference between the Imports(as % of merchandise exports) of Arab World in 2005 and the Imports(as % of merchandise exports) of Egypt, Arab Rep. in 2008?
Make the answer very short. -3.8. What is the difference between the Imports(as % of merchandise exports) in Arab World in 2005 and the Imports(as % of merchandise exports) in Mexico in 2008?
Give a very brief answer. -2.18. What is the difference between the Imports(as % of merchandise exports) of Arab World in 2005 and the Imports(as % of merchandise exports) of Suriname in 2008?
Offer a terse response. -8.24. What is the difference between the Imports(as % of merchandise exports) in Egypt, Arab Rep. in 2005 and the Imports(as % of merchandise exports) in Mexico in 2008?
Give a very brief answer. 4.03. What is the difference between the Imports(as % of merchandise exports) of Egypt, Arab Rep. in 2005 and the Imports(as % of merchandise exports) of Suriname in 2008?
Make the answer very short. -2.03. What is the difference between the Imports(as % of merchandise exports) of Mexico in 2005 and the Imports(as % of merchandise exports) of Suriname in 2008?
Offer a very short reply. -10.02. What is the difference between the Imports(as % of merchandise exports) of Arab World in 2007 and the Imports(as % of merchandise exports) of Egypt, Arab Rep. in 2008?
Offer a terse response. -3.09. What is the difference between the Imports(as % of merchandise exports) in Arab World in 2007 and the Imports(as % of merchandise exports) in Mexico in 2008?
Your answer should be compact. -1.47. What is the difference between the Imports(as % of merchandise exports) of Arab World in 2007 and the Imports(as % of merchandise exports) of Suriname in 2008?
Provide a short and direct response. -7.52. What is the difference between the Imports(as % of merchandise exports) of Egypt, Arab Rep. in 2007 and the Imports(as % of merchandise exports) of Mexico in 2008?
Offer a very short reply. 5.26. What is the difference between the Imports(as % of merchandise exports) of Egypt, Arab Rep. in 2007 and the Imports(as % of merchandise exports) of Suriname in 2008?
Provide a short and direct response. -0.8. What is the difference between the Imports(as % of merchandise exports) of Mexico in 2007 and the Imports(as % of merchandise exports) of Suriname in 2008?
Provide a short and direct response. -8.63. What is the average Imports(as % of merchandise exports) of Arab World per year?
Give a very brief answer. 7.06. What is the average Imports(as % of merchandise exports) of Egypt, Arab Rep. per year?
Your response must be concise. 8.88. What is the average Imports(as % of merchandise exports) of Mexico per year?
Provide a succinct answer. 5.02. What is the average Imports(as % of merchandise exports) in Suriname per year?
Your answer should be very brief. 15.54. In the year 2001, what is the difference between the Imports(as % of merchandise exports) of Arab World and Imports(as % of merchandise exports) of Egypt, Arab Rep.?
Offer a terse response. -0.13. In the year 2001, what is the difference between the Imports(as % of merchandise exports) in Arab World and Imports(as % of merchandise exports) in Mexico?
Offer a very short reply. 1.59. In the year 2001, what is the difference between the Imports(as % of merchandise exports) of Arab World and Imports(as % of merchandise exports) of Suriname?
Your answer should be compact. -12.36. In the year 2001, what is the difference between the Imports(as % of merchandise exports) in Egypt, Arab Rep. and Imports(as % of merchandise exports) in Mexico?
Offer a very short reply. 1.73. In the year 2001, what is the difference between the Imports(as % of merchandise exports) of Egypt, Arab Rep. and Imports(as % of merchandise exports) of Suriname?
Ensure brevity in your answer.  -12.23. In the year 2001, what is the difference between the Imports(as % of merchandise exports) in Mexico and Imports(as % of merchandise exports) in Suriname?
Give a very brief answer. -13.95. In the year 2002, what is the difference between the Imports(as % of merchandise exports) of Arab World and Imports(as % of merchandise exports) of Egypt, Arab Rep.?
Your answer should be compact. 1.68. In the year 2002, what is the difference between the Imports(as % of merchandise exports) of Arab World and Imports(as % of merchandise exports) of Mexico?
Provide a succinct answer. 3. In the year 2002, what is the difference between the Imports(as % of merchandise exports) of Arab World and Imports(as % of merchandise exports) of Suriname?
Your answer should be very brief. -8.68. In the year 2002, what is the difference between the Imports(as % of merchandise exports) of Egypt, Arab Rep. and Imports(as % of merchandise exports) of Mexico?
Provide a short and direct response. 1.32. In the year 2002, what is the difference between the Imports(as % of merchandise exports) of Egypt, Arab Rep. and Imports(as % of merchandise exports) of Suriname?
Provide a short and direct response. -10.35. In the year 2002, what is the difference between the Imports(as % of merchandise exports) of Mexico and Imports(as % of merchandise exports) of Suriname?
Offer a terse response. -11.67. In the year 2003, what is the difference between the Imports(as % of merchandise exports) of Arab World and Imports(as % of merchandise exports) of Egypt, Arab Rep.?
Provide a succinct answer. 2.8. In the year 2003, what is the difference between the Imports(as % of merchandise exports) in Arab World and Imports(as % of merchandise exports) in Mexico?
Keep it short and to the point. 4.58. In the year 2003, what is the difference between the Imports(as % of merchandise exports) of Arab World and Imports(as % of merchandise exports) of Suriname?
Offer a very short reply. -6.7. In the year 2003, what is the difference between the Imports(as % of merchandise exports) in Egypt, Arab Rep. and Imports(as % of merchandise exports) in Mexico?
Provide a succinct answer. 1.78. In the year 2003, what is the difference between the Imports(as % of merchandise exports) in Egypt, Arab Rep. and Imports(as % of merchandise exports) in Suriname?
Make the answer very short. -9.5. In the year 2003, what is the difference between the Imports(as % of merchandise exports) in Mexico and Imports(as % of merchandise exports) in Suriname?
Offer a very short reply. -11.28. In the year 2004, what is the difference between the Imports(as % of merchandise exports) in Arab World and Imports(as % of merchandise exports) in Egypt, Arab Rep.?
Your response must be concise. -1.1. In the year 2004, what is the difference between the Imports(as % of merchandise exports) in Arab World and Imports(as % of merchandise exports) in Mexico?
Provide a short and direct response. 3.62. In the year 2004, what is the difference between the Imports(as % of merchandise exports) of Arab World and Imports(as % of merchandise exports) of Suriname?
Offer a very short reply. -6.42. In the year 2004, what is the difference between the Imports(as % of merchandise exports) in Egypt, Arab Rep. and Imports(as % of merchandise exports) in Mexico?
Give a very brief answer. 4.71. In the year 2004, what is the difference between the Imports(as % of merchandise exports) of Egypt, Arab Rep. and Imports(as % of merchandise exports) of Suriname?
Provide a succinct answer. -5.33. In the year 2004, what is the difference between the Imports(as % of merchandise exports) in Mexico and Imports(as % of merchandise exports) in Suriname?
Your answer should be compact. -10.04. In the year 2005, what is the difference between the Imports(as % of merchandise exports) in Arab World and Imports(as % of merchandise exports) in Egypt, Arab Rep.?
Your answer should be compact. -6.21. In the year 2005, what is the difference between the Imports(as % of merchandise exports) of Arab World and Imports(as % of merchandise exports) of Mexico?
Your response must be concise. 1.78. In the year 2005, what is the difference between the Imports(as % of merchandise exports) of Arab World and Imports(as % of merchandise exports) of Suriname?
Your response must be concise. -9.84. In the year 2005, what is the difference between the Imports(as % of merchandise exports) in Egypt, Arab Rep. and Imports(as % of merchandise exports) in Mexico?
Offer a terse response. 7.99. In the year 2005, what is the difference between the Imports(as % of merchandise exports) of Egypt, Arab Rep. and Imports(as % of merchandise exports) of Suriname?
Make the answer very short. -3.63. In the year 2005, what is the difference between the Imports(as % of merchandise exports) of Mexico and Imports(as % of merchandise exports) of Suriname?
Your answer should be very brief. -11.62. In the year 2007, what is the difference between the Imports(as % of merchandise exports) of Arab World and Imports(as % of merchandise exports) of Egypt, Arab Rep.?
Keep it short and to the point. -6.72. In the year 2007, what is the difference between the Imports(as % of merchandise exports) in Arab World and Imports(as % of merchandise exports) in Mexico?
Provide a short and direct response. 1.1. In the year 2007, what is the difference between the Imports(as % of merchandise exports) of Arab World and Imports(as % of merchandise exports) of Suriname?
Give a very brief answer. -7.91. In the year 2007, what is the difference between the Imports(as % of merchandise exports) in Egypt, Arab Rep. and Imports(as % of merchandise exports) in Mexico?
Your answer should be compact. 7.83. In the year 2007, what is the difference between the Imports(as % of merchandise exports) of Egypt, Arab Rep. and Imports(as % of merchandise exports) of Suriname?
Your answer should be very brief. -1.19. In the year 2007, what is the difference between the Imports(as % of merchandise exports) in Mexico and Imports(as % of merchandise exports) in Suriname?
Provide a succinct answer. -9.01. In the year 2008, what is the difference between the Imports(as % of merchandise exports) in Arab World and Imports(as % of merchandise exports) in Egypt, Arab Rep.?
Offer a very short reply. -3.05. In the year 2008, what is the difference between the Imports(as % of merchandise exports) of Arab World and Imports(as % of merchandise exports) of Mexico?
Ensure brevity in your answer.  -1.43. In the year 2008, what is the difference between the Imports(as % of merchandise exports) of Arab World and Imports(as % of merchandise exports) of Suriname?
Provide a short and direct response. -7.48. In the year 2008, what is the difference between the Imports(as % of merchandise exports) in Egypt, Arab Rep. and Imports(as % of merchandise exports) in Mexico?
Your answer should be very brief. 1.62. In the year 2008, what is the difference between the Imports(as % of merchandise exports) of Egypt, Arab Rep. and Imports(as % of merchandise exports) of Suriname?
Your response must be concise. -4.43. In the year 2008, what is the difference between the Imports(as % of merchandise exports) of Mexico and Imports(as % of merchandise exports) of Suriname?
Give a very brief answer. -6.05. What is the ratio of the Imports(as % of merchandise exports) of Arab World in 2001 to that in 2002?
Your answer should be very brief. 0.84. What is the ratio of the Imports(as % of merchandise exports) in Egypt, Arab Rep. in 2001 to that in 2002?
Ensure brevity in your answer.  1.23. What is the ratio of the Imports(as % of merchandise exports) in Mexico in 2001 to that in 2002?
Give a very brief answer. 1.19. What is the ratio of the Imports(as % of merchandise exports) in Suriname in 2001 to that in 2002?
Ensure brevity in your answer.  1.19. What is the ratio of the Imports(as % of merchandise exports) in Arab World in 2001 to that in 2003?
Make the answer very short. 0.6. What is the ratio of the Imports(as % of merchandise exports) in Egypt, Arab Rep. in 2001 to that in 2003?
Your answer should be compact. 0.95. What is the ratio of the Imports(as % of merchandise exports) in Mexico in 2001 to that in 2003?
Offer a terse response. 0.94. What is the ratio of the Imports(as % of merchandise exports) in Suriname in 2001 to that in 2003?
Provide a succinct answer. 1.17. What is the ratio of the Imports(as % of merchandise exports) of Arab World in 2001 to that in 2004?
Your answer should be very brief. 0.64. What is the ratio of the Imports(as % of merchandise exports) in Egypt, Arab Rep. in 2001 to that in 2004?
Ensure brevity in your answer.  0.57. What is the ratio of the Imports(as % of merchandise exports) of Mexico in 2001 to that in 2004?
Give a very brief answer. 0.83. What is the ratio of the Imports(as % of merchandise exports) of Suriname in 2001 to that in 2004?
Make the answer very short. 1.23. What is the ratio of the Imports(as % of merchandise exports) in Arab World in 2001 to that in 2005?
Make the answer very short. 0.66. What is the ratio of the Imports(as % of merchandise exports) of Egypt, Arab Rep. in 2001 to that in 2005?
Your answer should be very brief. 0.36. What is the ratio of the Imports(as % of merchandise exports) of Mexico in 2001 to that in 2005?
Your response must be concise. 0.58. What is the ratio of the Imports(as % of merchandise exports) of Suriname in 2001 to that in 2005?
Provide a short and direct response. 1. What is the ratio of the Imports(as % of merchandise exports) in Arab World in 2001 to that in 2007?
Ensure brevity in your answer.  0.6. What is the ratio of the Imports(as % of merchandise exports) in Egypt, Arab Rep. in 2001 to that in 2007?
Offer a terse response. 0.33. What is the ratio of the Imports(as % of merchandise exports) of Mexico in 2001 to that in 2007?
Offer a very short reply. 0.46. What is the ratio of the Imports(as % of merchandise exports) of Suriname in 2001 to that in 2007?
Provide a succinct answer. 1.08. What is the ratio of the Imports(as % of merchandise exports) in Arab World in 2001 to that in 2008?
Provide a succinct answer. 0.59. What is the ratio of the Imports(as % of merchandise exports) in Egypt, Arab Rep. in 2001 to that in 2008?
Give a very brief answer. 0.44. What is the ratio of the Imports(as % of merchandise exports) of Mexico in 2001 to that in 2008?
Your response must be concise. 0.34. What is the ratio of the Imports(as % of merchandise exports) of Suriname in 2001 to that in 2008?
Your response must be concise. 1.1. What is the ratio of the Imports(as % of merchandise exports) of Arab World in 2002 to that in 2003?
Offer a very short reply. 0.71. What is the ratio of the Imports(as % of merchandise exports) in Egypt, Arab Rep. in 2002 to that in 2003?
Make the answer very short. 0.78. What is the ratio of the Imports(as % of merchandise exports) in Mexico in 2002 to that in 2003?
Provide a short and direct response. 0.79. What is the ratio of the Imports(as % of merchandise exports) in Suriname in 2002 to that in 2003?
Ensure brevity in your answer.  0.98. What is the ratio of the Imports(as % of merchandise exports) of Arab World in 2002 to that in 2004?
Your answer should be compact. 0.76. What is the ratio of the Imports(as % of merchandise exports) of Egypt, Arab Rep. in 2002 to that in 2004?
Ensure brevity in your answer.  0.47. What is the ratio of the Imports(as % of merchandise exports) of Mexico in 2002 to that in 2004?
Your answer should be very brief. 0.69. What is the ratio of the Imports(as % of merchandise exports) of Suriname in 2002 to that in 2004?
Your response must be concise. 1.03. What is the ratio of the Imports(as % of merchandise exports) of Egypt, Arab Rep. in 2002 to that in 2005?
Your answer should be very brief. 0.3. What is the ratio of the Imports(as % of merchandise exports) in Mexico in 2002 to that in 2005?
Keep it short and to the point. 0.49. What is the ratio of the Imports(as % of merchandise exports) in Suriname in 2002 to that in 2005?
Your response must be concise. 0.84. What is the ratio of the Imports(as % of merchandise exports) of Arab World in 2002 to that in 2007?
Provide a short and direct response. 0.71. What is the ratio of the Imports(as % of merchandise exports) in Egypt, Arab Rep. in 2002 to that in 2007?
Your answer should be compact. 0.27. What is the ratio of the Imports(as % of merchandise exports) of Mexico in 2002 to that in 2007?
Your answer should be very brief. 0.39. What is the ratio of the Imports(as % of merchandise exports) of Suriname in 2002 to that in 2007?
Your answer should be compact. 0.9. What is the ratio of the Imports(as % of merchandise exports) of Arab World in 2002 to that in 2008?
Keep it short and to the point. 0.7. What is the ratio of the Imports(as % of merchandise exports) of Egypt, Arab Rep. in 2002 to that in 2008?
Keep it short and to the point. 0.36. What is the ratio of the Imports(as % of merchandise exports) in Mexico in 2002 to that in 2008?
Offer a very short reply. 0.28. What is the ratio of the Imports(as % of merchandise exports) of Suriname in 2002 to that in 2008?
Your answer should be very brief. 0.92. What is the ratio of the Imports(as % of merchandise exports) in Arab World in 2003 to that in 2004?
Your answer should be compact. 1.06. What is the ratio of the Imports(as % of merchandise exports) of Egypt, Arab Rep. in 2003 to that in 2004?
Provide a succinct answer. 0.6. What is the ratio of the Imports(as % of merchandise exports) in Mexico in 2003 to that in 2004?
Provide a short and direct response. 0.88. What is the ratio of the Imports(as % of merchandise exports) of Suriname in 2003 to that in 2004?
Your answer should be compact. 1.05. What is the ratio of the Imports(as % of merchandise exports) of Arab World in 2003 to that in 2005?
Provide a short and direct response. 1.09. What is the ratio of the Imports(as % of merchandise exports) of Egypt, Arab Rep. in 2003 to that in 2005?
Give a very brief answer. 0.38. What is the ratio of the Imports(as % of merchandise exports) of Mexico in 2003 to that in 2005?
Your answer should be very brief. 0.61. What is the ratio of the Imports(as % of merchandise exports) in Suriname in 2003 to that in 2005?
Your response must be concise. 0.86. What is the ratio of the Imports(as % of merchandise exports) in Egypt, Arab Rep. in 2003 to that in 2007?
Provide a succinct answer. 0.35. What is the ratio of the Imports(as % of merchandise exports) of Mexico in 2003 to that in 2007?
Make the answer very short. 0.49. What is the ratio of the Imports(as % of merchandise exports) in Suriname in 2003 to that in 2007?
Ensure brevity in your answer.  0.92. What is the ratio of the Imports(as % of merchandise exports) of Arab World in 2003 to that in 2008?
Provide a succinct answer. 0.99. What is the ratio of the Imports(as % of merchandise exports) in Egypt, Arab Rep. in 2003 to that in 2008?
Offer a terse response. 0.47. What is the ratio of the Imports(as % of merchandise exports) in Mexico in 2003 to that in 2008?
Offer a terse response. 0.36. What is the ratio of the Imports(as % of merchandise exports) of Suriname in 2003 to that in 2008?
Offer a very short reply. 0.94. What is the ratio of the Imports(as % of merchandise exports) of Arab World in 2004 to that in 2005?
Your answer should be compact. 1.02. What is the ratio of the Imports(as % of merchandise exports) in Egypt, Arab Rep. in 2004 to that in 2005?
Provide a succinct answer. 0.64. What is the ratio of the Imports(as % of merchandise exports) of Mexico in 2004 to that in 2005?
Keep it short and to the point. 0.7. What is the ratio of the Imports(as % of merchandise exports) in Suriname in 2004 to that in 2005?
Provide a short and direct response. 0.81. What is the ratio of the Imports(as % of merchandise exports) in Arab World in 2004 to that in 2007?
Ensure brevity in your answer.  0.93. What is the ratio of the Imports(as % of merchandise exports) in Egypt, Arab Rep. in 2004 to that in 2007?
Provide a short and direct response. 0.58. What is the ratio of the Imports(as % of merchandise exports) of Mexico in 2004 to that in 2007?
Provide a short and direct response. 0.56. What is the ratio of the Imports(as % of merchandise exports) in Suriname in 2004 to that in 2007?
Give a very brief answer. 0.87. What is the ratio of the Imports(as % of merchandise exports) of Arab World in 2004 to that in 2008?
Ensure brevity in your answer.  0.93. What is the ratio of the Imports(as % of merchandise exports) of Egypt, Arab Rep. in 2004 to that in 2008?
Your response must be concise. 0.77. What is the ratio of the Imports(as % of merchandise exports) in Mexico in 2004 to that in 2008?
Keep it short and to the point. 0.41. What is the ratio of the Imports(as % of merchandise exports) of Suriname in 2004 to that in 2008?
Your response must be concise. 0.9. What is the ratio of the Imports(as % of merchandise exports) of Arab World in 2005 to that in 2007?
Make the answer very short. 0.91. What is the ratio of the Imports(as % of merchandise exports) of Egypt, Arab Rep. in 2005 to that in 2007?
Ensure brevity in your answer.  0.92. What is the ratio of the Imports(as % of merchandise exports) in Mexico in 2005 to that in 2007?
Your answer should be compact. 0.8. What is the ratio of the Imports(as % of merchandise exports) in Suriname in 2005 to that in 2007?
Provide a succinct answer. 1.08. What is the ratio of the Imports(as % of merchandise exports) in Arab World in 2005 to that in 2008?
Offer a very short reply. 0.91. What is the ratio of the Imports(as % of merchandise exports) in Egypt, Arab Rep. in 2005 to that in 2008?
Your response must be concise. 1.22. What is the ratio of the Imports(as % of merchandise exports) of Mexico in 2005 to that in 2008?
Your answer should be very brief. 0.58. What is the ratio of the Imports(as % of merchandise exports) of Suriname in 2005 to that in 2008?
Make the answer very short. 1.1. What is the ratio of the Imports(as % of merchandise exports) in Arab World in 2007 to that in 2008?
Your answer should be compact. 0.99. What is the ratio of the Imports(as % of merchandise exports) of Egypt, Arab Rep. in 2007 to that in 2008?
Your response must be concise. 1.33. What is the ratio of the Imports(as % of merchandise exports) in Mexico in 2007 to that in 2008?
Your response must be concise. 0.73. What is the ratio of the Imports(as % of merchandise exports) of Suriname in 2007 to that in 2008?
Make the answer very short. 1.02. What is the difference between the highest and the second highest Imports(as % of merchandise exports) of Arab World?
Keep it short and to the point. 0.04. What is the difference between the highest and the second highest Imports(as % of merchandise exports) in Egypt, Arab Rep.?
Your response must be concise. 1.23. What is the difference between the highest and the second highest Imports(as % of merchandise exports) of Mexico?
Offer a terse response. 2.57. What is the difference between the highest and the second highest Imports(as % of merchandise exports) of Suriname?
Keep it short and to the point. 0. What is the difference between the highest and the lowest Imports(as % of merchandise exports) in Arab World?
Ensure brevity in your answer.  3.28. What is the difference between the highest and the lowest Imports(as % of merchandise exports) of Egypt, Arab Rep.?
Your answer should be very brief. 10.74. What is the difference between the highest and the lowest Imports(as % of merchandise exports) in Mexico?
Offer a very short reply. 6.81. What is the difference between the highest and the lowest Imports(as % of merchandise exports) of Suriname?
Provide a succinct answer. 3.24. 